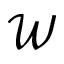<formula> <loc_0><loc_0><loc_500><loc_500>\mathcal { W }</formula> 